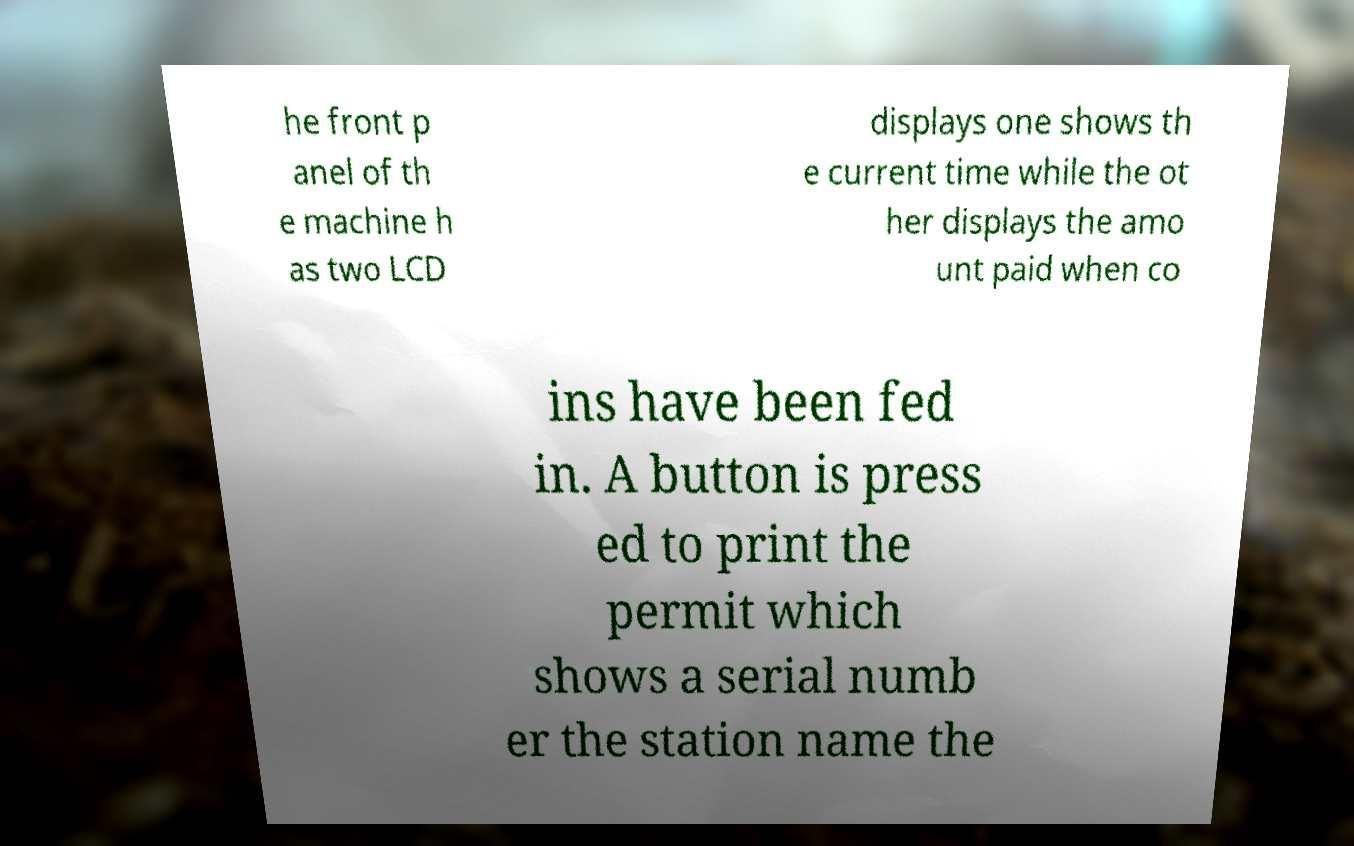For documentation purposes, I need the text within this image transcribed. Could you provide that? he front p anel of th e machine h as two LCD displays one shows th e current time while the ot her displays the amo unt paid when co ins have been fed in. A button is press ed to print the permit which shows a serial numb er the station name the 